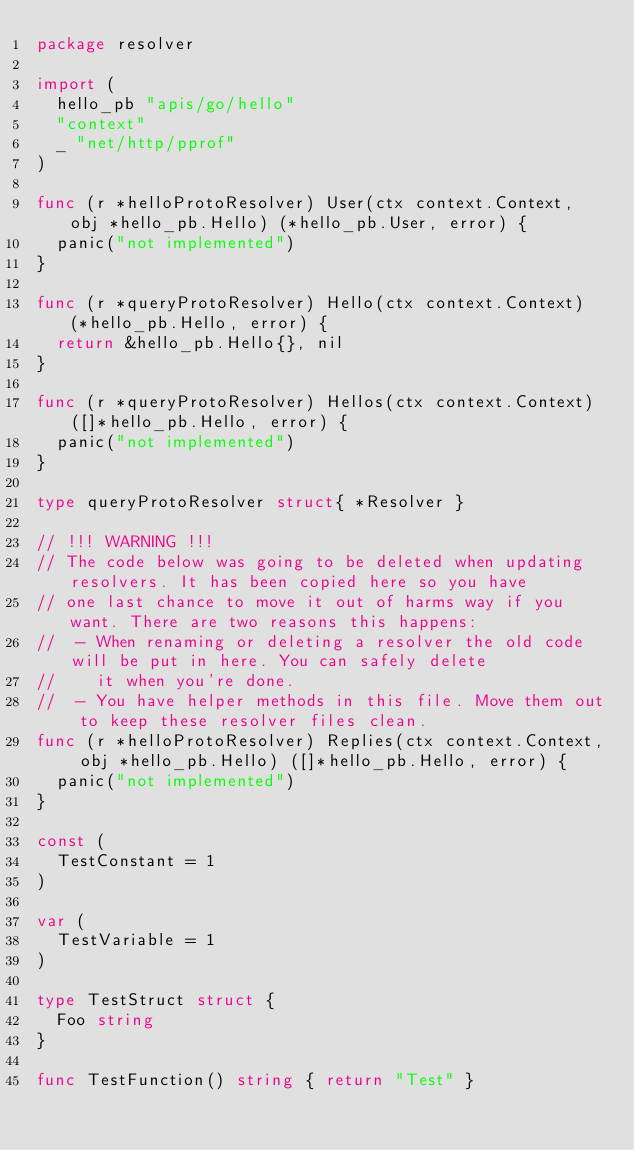<code> <loc_0><loc_0><loc_500><loc_500><_Go_>package resolver

import (
	hello_pb "apis/go/hello"
	"context"
	_ "net/http/pprof"
)

func (r *helloProtoResolver) User(ctx context.Context, obj *hello_pb.Hello) (*hello_pb.User, error) {
	panic("not implemented")
}

func (r *queryProtoResolver) Hello(ctx context.Context) (*hello_pb.Hello, error) {
	return &hello_pb.Hello{}, nil
}

func (r *queryProtoResolver) Hellos(ctx context.Context) ([]*hello_pb.Hello, error) {
	panic("not implemented")
}

type queryProtoResolver struct{ *Resolver }

// !!! WARNING !!!
// The code below was going to be deleted when updating resolvers. It has been copied here so you have
// one last chance to move it out of harms way if you want. There are two reasons this happens:
//  - When renaming or deleting a resolver the old code will be put in here. You can safely delete
//    it when you're done.
//  - You have helper methods in this file. Move them out to keep these resolver files clean.
func (r *helloProtoResolver) Replies(ctx context.Context, obj *hello_pb.Hello) ([]*hello_pb.Hello, error) {
	panic("not implemented")
}

const (
	TestConstant = 1
)

var (
	TestVariable = 1
)

type TestStruct struct {
	Foo string
}

func TestFunction() string { return "Test" }

</code> 